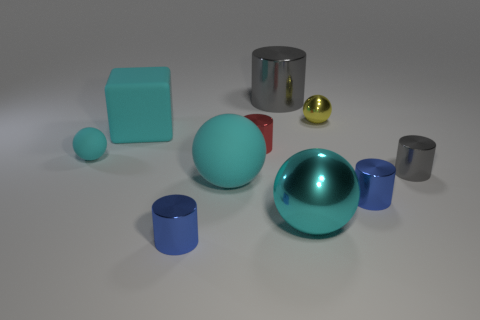What material is the tiny ball that is the same color as the cube?
Offer a terse response. Rubber. There is a small thing that is both on the left side of the red cylinder and in front of the small rubber sphere; what shape is it?
Make the answer very short. Cylinder. There is a blue cylinder that is to the left of the tiny ball that is on the right side of the big cube; what is it made of?
Your response must be concise. Metal. Is the number of large metal spheres greater than the number of large brown things?
Keep it short and to the point. Yes. Does the big metallic cylinder have the same color as the large block?
Your response must be concise. No. What is the material of the other sphere that is the same size as the cyan metallic ball?
Give a very brief answer. Rubber. Are the tiny yellow object and the large block made of the same material?
Keep it short and to the point. No. How many tiny balls are made of the same material as the big gray cylinder?
Provide a succinct answer. 1. How many objects are tiny yellow shiny spheres to the right of the red shiny object or cylinders to the left of the small yellow object?
Keep it short and to the point. 4. Is the number of tiny spheres that are on the left side of the small matte object greater than the number of blue cylinders right of the small red metallic thing?
Offer a terse response. No. 